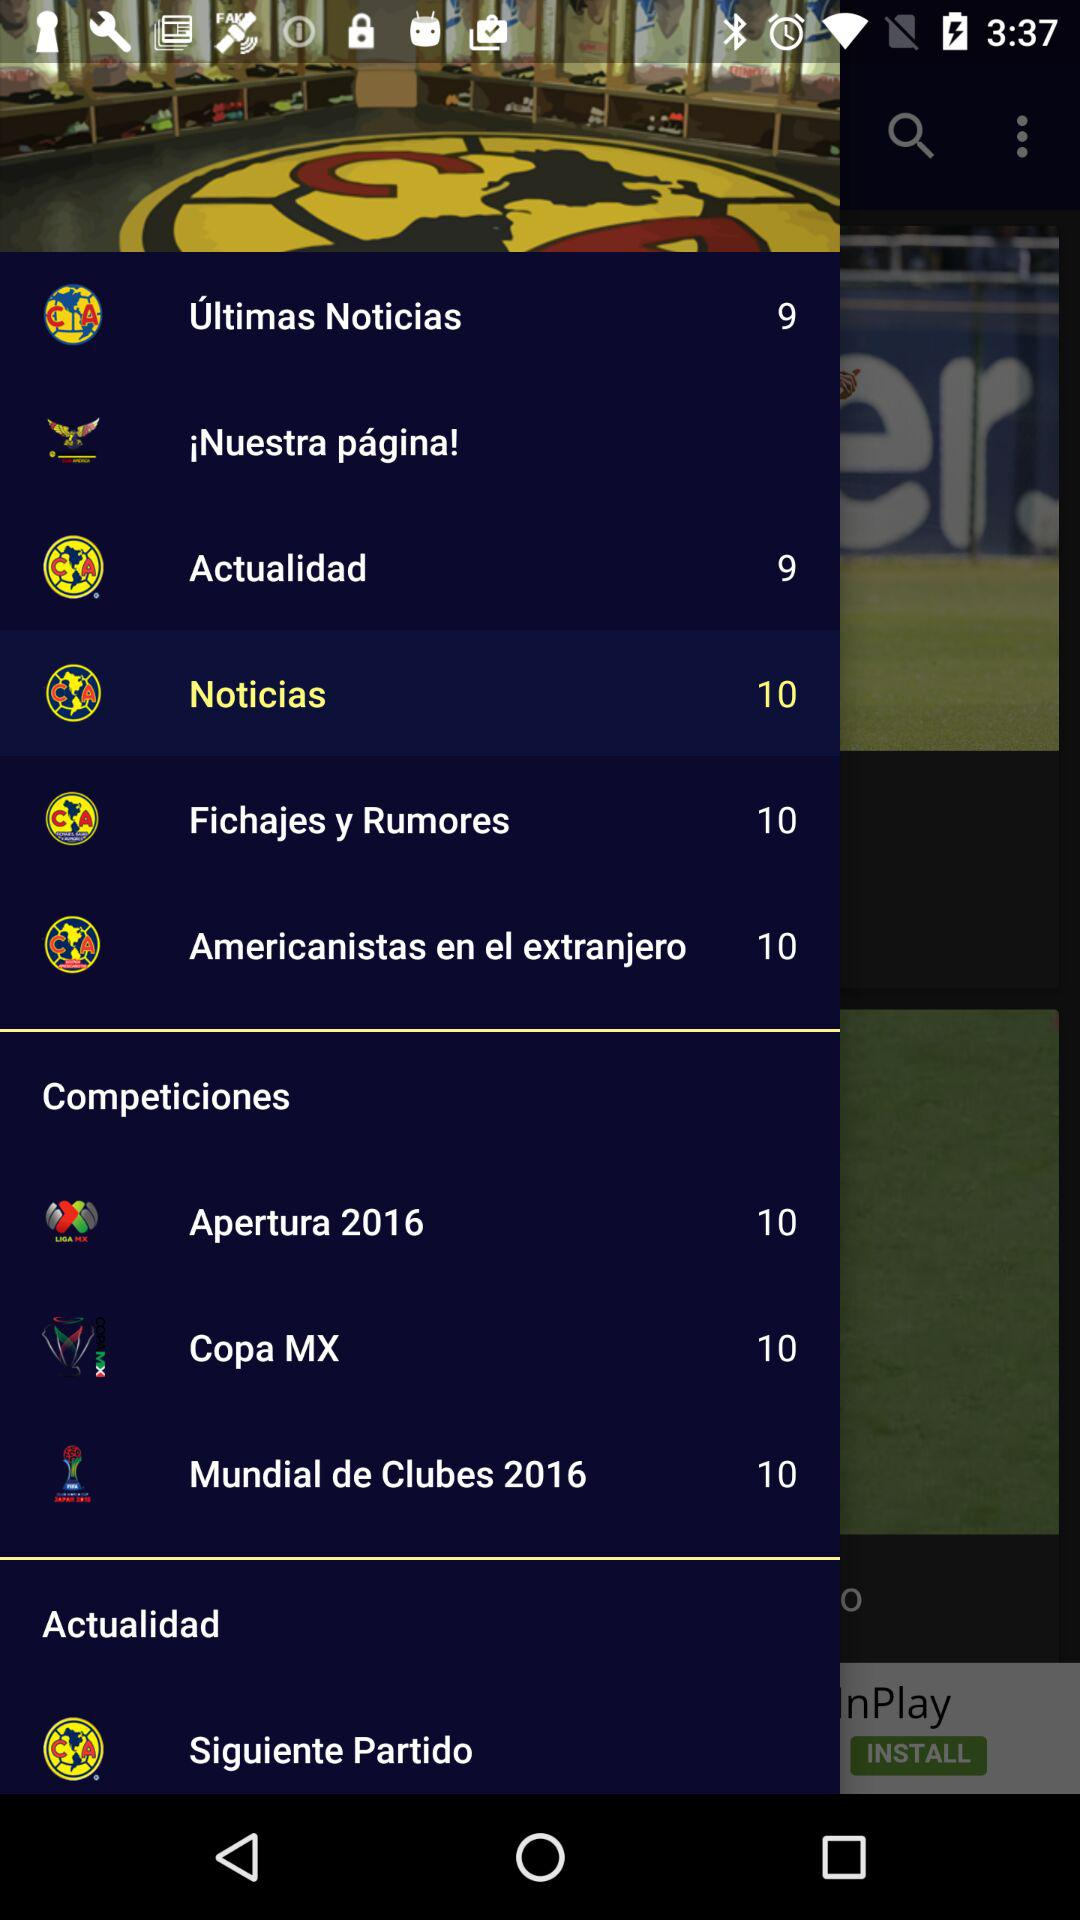How many items are in the Competiciones section?
Answer the question using a single word or phrase. 3 